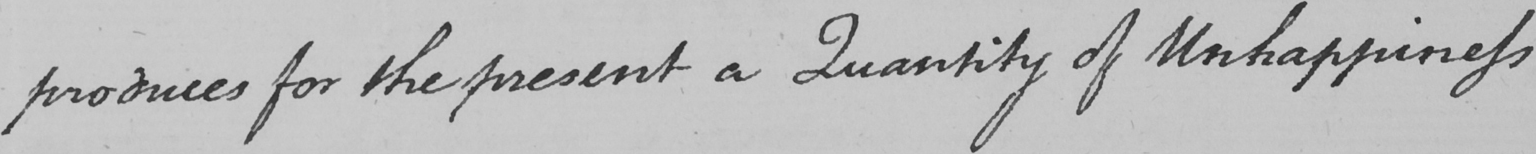Please provide the text content of this handwritten line. produces for the present a Quantity of Unhappiness 